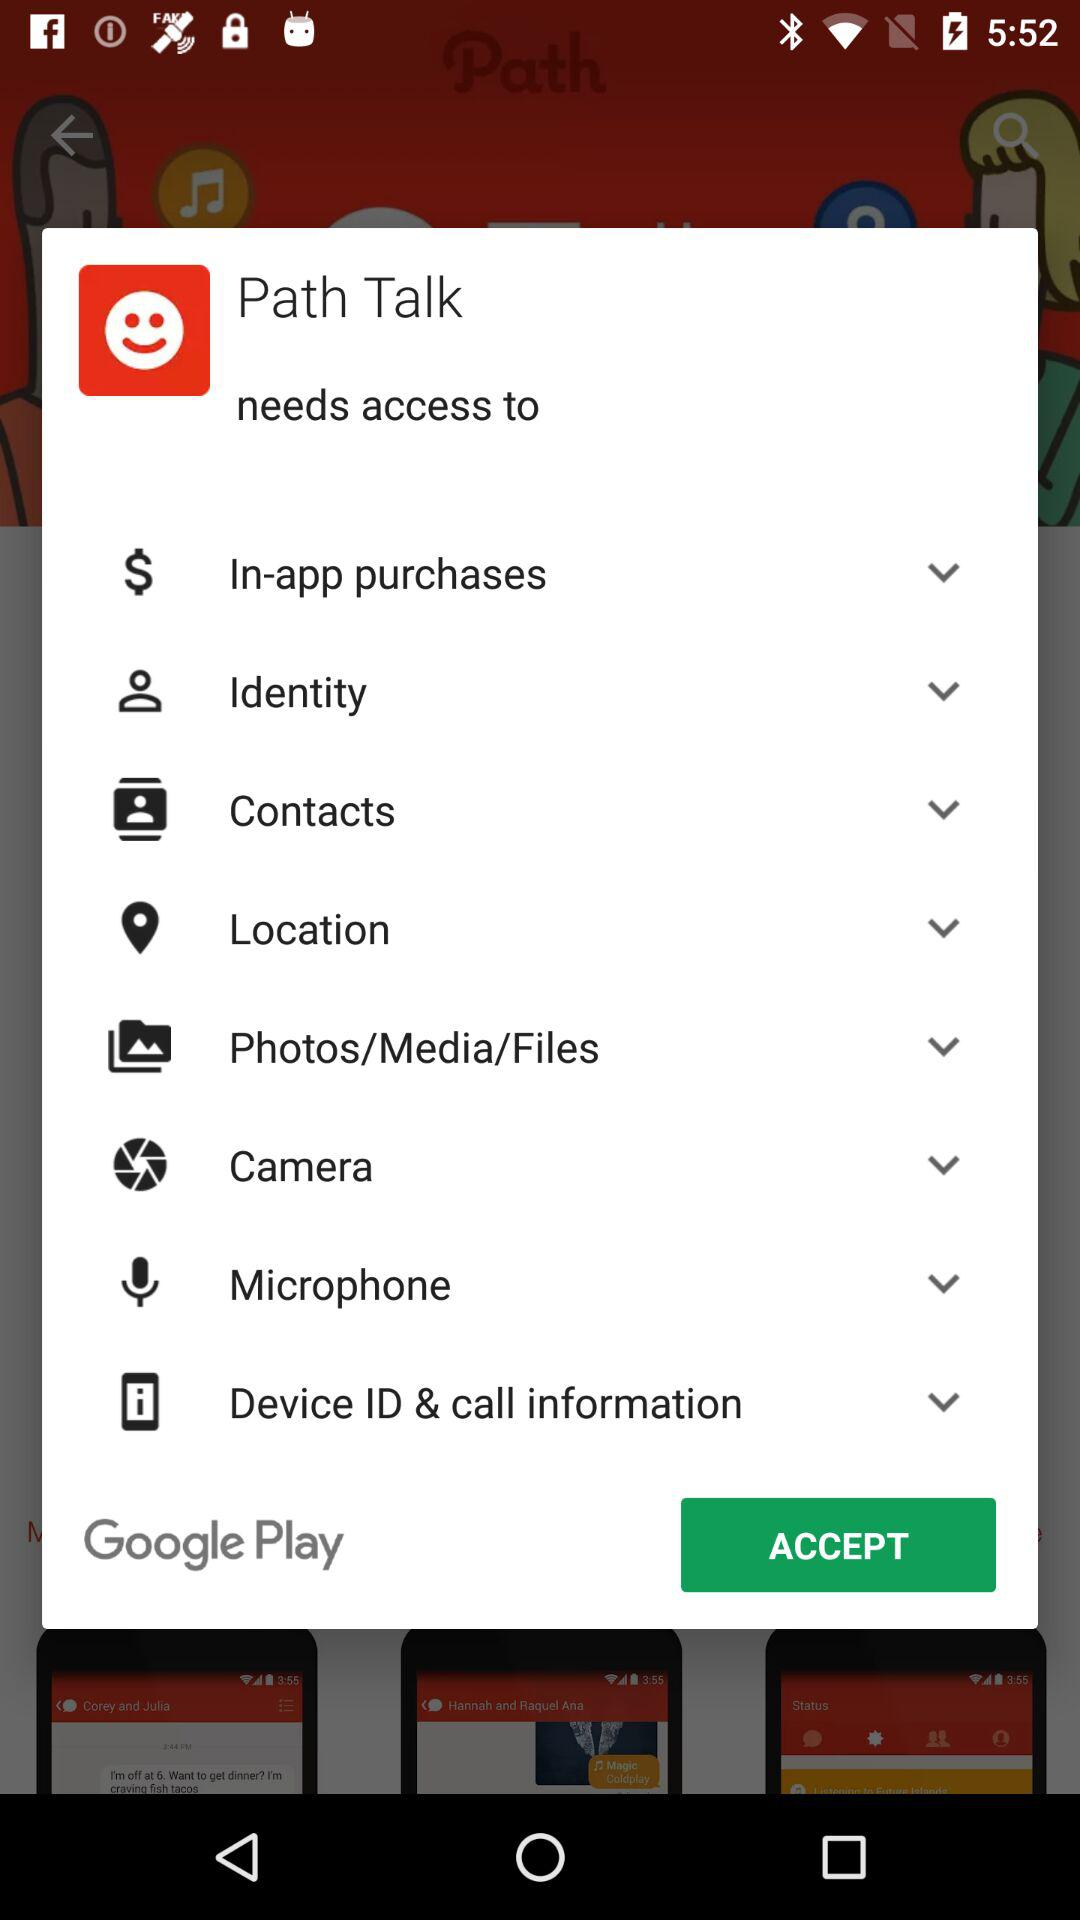How many items can be turned on or off?
Answer the question using a single word or phrase. 8 